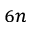Convert formula to latex. <formula><loc_0><loc_0><loc_500><loc_500>_ { 6 n }</formula> 